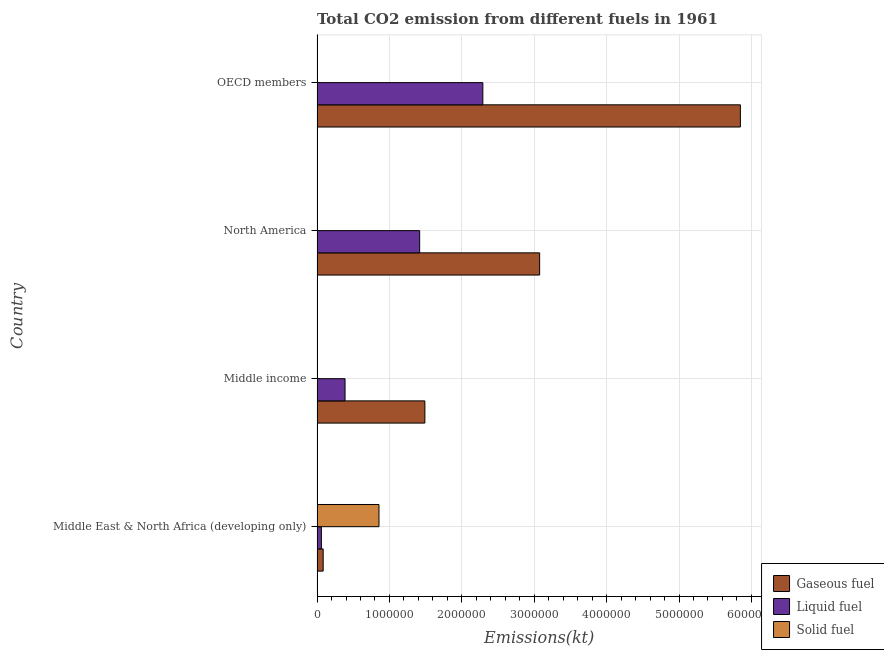How many groups of bars are there?
Your answer should be very brief. 4. Are the number of bars on each tick of the Y-axis equal?
Offer a terse response. Yes. What is the label of the 2nd group of bars from the top?
Your answer should be compact. North America. In how many cases, is the number of bars for a given country not equal to the number of legend labels?
Offer a very short reply. 0. What is the amount of co2 emissions from liquid fuel in Middle East & North Africa (developing only)?
Make the answer very short. 5.98e+04. Across all countries, what is the maximum amount of co2 emissions from gaseous fuel?
Keep it short and to the point. 5.85e+06. Across all countries, what is the minimum amount of co2 emissions from gaseous fuel?
Your response must be concise. 8.46e+04. In which country was the amount of co2 emissions from liquid fuel minimum?
Your answer should be very brief. Middle East & North Africa (developing only). What is the total amount of co2 emissions from gaseous fuel in the graph?
Provide a short and direct response. 1.05e+07. What is the difference between the amount of co2 emissions from liquid fuel in Middle East & North Africa (developing only) and that in OECD members?
Provide a succinct answer. -2.23e+06. What is the difference between the amount of co2 emissions from gaseous fuel in OECD members and the amount of co2 emissions from liquid fuel in Middle East & North Africa (developing only)?
Give a very brief answer. 5.79e+06. What is the average amount of co2 emissions from gaseous fuel per country?
Provide a short and direct response. 2.62e+06. What is the difference between the amount of co2 emissions from solid fuel and amount of co2 emissions from liquid fuel in OECD members?
Provide a short and direct response. -2.29e+06. In how many countries, is the amount of co2 emissions from liquid fuel greater than 5200000 kt?
Offer a terse response. 0. What is the ratio of the amount of co2 emissions from solid fuel in Middle income to that in OECD members?
Provide a succinct answer. 0.23. Is the difference between the amount of co2 emissions from solid fuel in Middle income and OECD members greater than the difference between the amount of co2 emissions from liquid fuel in Middle income and OECD members?
Provide a short and direct response. Yes. What is the difference between the highest and the second highest amount of co2 emissions from solid fuel?
Your response must be concise. 8.55e+05. What is the difference between the highest and the lowest amount of co2 emissions from solid fuel?
Your answer should be compact. 8.55e+05. What does the 3rd bar from the top in Middle East & North Africa (developing only) represents?
Offer a terse response. Gaseous fuel. What does the 1st bar from the bottom in Middle East & North Africa (developing only) represents?
Make the answer very short. Gaseous fuel. How many bars are there?
Keep it short and to the point. 12. Are all the bars in the graph horizontal?
Keep it short and to the point. Yes. Does the graph contain grids?
Ensure brevity in your answer.  Yes. How are the legend labels stacked?
Give a very brief answer. Vertical. What is the title of the graph?
Offer a terse response. Total CO2 emission from different fuels in 1961. What is the label or title of the X-axis?
Provide a succinct answer. Emissions(kt). What is the label or title of the Y-axis?
Make the answer very short. Country. What is the Emissions(kt) of Gaseous fuel in Middle East & North Africa (developing only)?
Your response must be concise. 8.46e+04. What is the Emissions(kt) of Liquid fuel in Middle East & North Africa (developing only)?
Ensure brevity in your answer.  5.98e+04. What is the Emissions(kt) of Solid fuel in Middle East & North Africa (developing only)?
Your response must be concise. 8.56e+05. What is the Emissions(kt) in Gaseous fuel in Middle income?
Make the answer very short. 1.49e+06. What is the Emissions(kt) of Liquid fuel in Middle income?
Provide a succinct answer. 3.87e+05. What is the Emissions(kt) in Solid fuel in Middle income?
Keep it short and to the point. 176.02. What is the Emissions(kt) of Gaseous fuel in North America?
Give a very brief answer. 3.07e+06. What is the Emissions(kt) in Liquid fuel in North America?
Provide a succinct answer. 1.42e+06. What is the Emissions(kt) in Solid fuel in North America?
Offer a terse response. 322.7. What is the Emissions(kt) of Gaseous fuel in OECD members?
Give a very brief answer. 5.85e+06. What is the Emissions(kt) of Liquid fuel in OECD members?
Your answer should be compact. 2.29e+06. What is the Emissions(kt) of Solid fuel in OECD members?
Keep it short and to the point. 766.4. Across all countries, what is the maximum Emissions(kt) in Gaseous fuel?
Your answer should be compact. 5.85e+06. Across all countries, what is the maximum Emissions(kt) of Liquid fuel?
Ensure brevity in your answer.  2.29e+06. Across all countries, what is the maximum Emissions(kt) in Solid fuel?
Your response must be concise. 8.56e+05. Across all countries, what is the minimum Emissions(kt) in Gaseous fuel?
Provide a short and direct response. 8.46e+04. Across all countries, what is the minimum Emissions(kt) in Liquid fuel?
Provide a short and direct response. 5.98e+04. Across all countries, what is the minimum Emissions(kt) of Solid fuel?
Offer a terse response. 176.02. What is the total Emissions(kt) of Gaseous fuel in the graph?
Keep it short and to the point. 1.05e+07. What is the total Emissions(kt) of Liquid fuel in the graph?
Offer a terse response. 4.15e+06. What is the total Emissions(kt) of Solid fuel in the graph?
Your response must be concise. 8.57e+05. What is the difference between the Emissions(kt) in Gaseous fuel in Middle East & North Africa (developing only) and that in Middle income?
Your answer should be compact. -1.40e+06. What is the difference between the Emissions(kt) of Liquid fuel in Middle East & North Africa (developing only) and that in Middle income?
Give a very brief answer. -3.27e+05. What is the difference between the Emissions(kt) of Solid fuel in Middle East & North Africa (developing only) and that in Middle income?
Keep it short and to the point. 8.55e+05. What is the difference between the Emissions(kt) of Gaseous fuel in Middle East & North Africa (developing only) and that in North America?
Give a very brief answer. -2.99e+06. What is the difference between the Emissions(kt) in Liquid fuel in Middle East & North Africa (developing only) and that in North America?
Your response must be concise. -1.36e+06. What is the difference between the Emissions(kt) in Solid fuel in Middle East & North Africa (developing only) and that in North America?
Make the answer very short. 8.55e+05. What is the difference between the Emissions(kt) in Gaseous fuel in Middle East & North Africa (developing only) and that in OECD members?
Ensure brevity in your answer.  -5.76e+06. What is the difference between the Emissions(kt) of Liquid fuel in Middle East & North Africa (developing only) and that in OECD members?
Your answer should be very brief. -2.23e+06. What is the difference between the Emissions(kt) in Solid fuel in Middle East & North Africa (developing only) and that in OECD members?
Make the answer very short. 8.55e+05. What is the difference between the Emissions(kt) in Gaseous fuel in Middle income and that in North America?
Provide a short and direct response. -1.59e+06. What is the difference between the Emissions(kt) in Liquid fuel in Middle income and that in North America?
Your answer should be compact. -1.03e+06. What is the difference between the Emissions(kt) in Solid fuel in Middle income and that in North America?
Offer a terse response. -146.68. What is the difference between the Emissions(kt) in Gaseous fuel in Middle income and that in OECD members?
Your answer should be very brief. -4.36e+06. What is the difference between the Emissions(kt) of Liquid fuel in Middle income and that in OECD members?
Provide a succinct answer. -1.90e+06. What is the difference between the Emissions(kt) of Solid fuel in Middle income and that in OECD members?
Offer a very short reply. -590.39. What is the difference between the Emissions(kt) in Gaseous fuel in North America and that in OECD members?
Provide a short and direct response. -2.77e+06. What is the difference between the Emissions(kt) in Liquid fuel in North America and that in OECD members?
Give a very brief answer. -8.73e+05. What is the difference between the Emissions(kt) of Solid fuel in North America and that in OECD members?
Offer a terse response. -443.71. What is the difference between the Emissions(kt) in Gaseous fuel in Middle East & North Africa (developing only) and the Emissions(kt) in Liquid fuel in Middle income?
Offer a terse response. -3.02e+05. What is the difference between the Emissions(kt) in Gaseous fuel in Middle East & North Africa (developing only) and the Emissions(kt) in Solid fuel in Middle income?
Your response must be concise. 8.45e+04. What is the difference between the Emissions(kt) in Liquid fuel in Middle East & North Africa (developing only) and the Emissions(kt) in Solid fuel in Middle income?
Your response must be concise. 5.96e+04. What is the difference between the Emissions(kt) of Gaseous fuel in Middle East & North Africa (developing only) and the Emissions(kt) of Liquid fuel in North America?
Make the answer very short. -1.33e+06. What is the difference between the Emissions(kt) in Gaseous fuel in Middle East & North Africa (developing only) and the Emissions(kt) in Solid fuel in North America?
Make the answer very short. 8.43e+04. What is the difference between the Emissions(kt) in Liquid fuel in Middle East & North Africa (developing only) and the Emissions(kt) in Solid fuel in North America?
Provide a succinct answer. 5.94e+04. What is the difference between the Emissions(kt) in Gaseous fuel in Middle East & North Africa (developing only) and the Emissions(kt) in Liquid fuel in OECD members?
Give a very brief answer. -2.21e+06. What is the difference between the Emissions(kt) of Gaseous fuel in Middle East & North Africa (developing only) and the Emissions(kt) of Solid fuel in OECD members?
Give a very brief answer. 8.39e+04. What is the difference between the Emissions(kt) in Liquid fuel in Middle East & North Africa (developing only) and the Emissions(kt) in Solid fuel in OECD members?
Your answer should be very brief. 5.90e+04. What is the difference between the Emissions(kt) in Gaseous fuel in Middle income and the Emissions(kt) in Liquid fuel in North America?
Make the answer very short. 7.21e+04. What is the difference between the Emissions(kt) of Gaseous fuel in Middle income and the Emissions(kt) of Solid fuel in North America?
Your answer should be compact. 1.49e+06. What is the difference between the Emissions(kt) in Liquid fuel in Middle income and the Emissions(kt) in Solid fuel in North America?
Keep it short and to the point. 3.86e+05. What is the difference between the Emissions(kt) of Gaseous fuel in Middle income and the Emissions(kt) of Liquid fuel in OECD members?
Provide a succinct answer. -8.01e+05. What is the difference between the Emissions(kt) in Gaseous fuel in Middle income and the Emissions(kt) in Solid fuel in OECD members?
Give a very brief answer. 1.49e+06. What is the difference between the Emissions(kt) of Liquid fuel in Middle income and the Emissions(kt) of Solid fuel in OECD members?
Make the answer very short. 3.86e+05. What is the difference between the Emissions(kt) of Gaseous fuel in North America and the Emissions(kt) of Liquid fuel in OECD members?
Keep it short and to the point. 7.85e+05. What is the difference between the Emissions(kt) in Gaseous fuel in North America and the Emissions(kt) in Solid fuel in OECD members?
Your response must be concise. 3.07e+06. What is the difference between the Emissions(kt) in Liquid fuel in North America and the Emissions(kt) in Solid fuel in OECD members?
Offer a very short reply. 1.42e+06. What is the average Emissions(kt) of Gaseous fuel per country?
Make the answer very short. 2.62e+06. What is the average Emissions(kt) of Liquid fuel per country?
Your response must be concise. 1.04e+06. What is the average Emissions(kt) in Solid fuel per country?
Offer a very short reply. 2.14e+05. What is the difference between the Emissions(kt) of Gaseous fuel and Emissions(kt) of Liquid fuel in Middle East & North Africa (developing only)?
Provide a short and direct response. 2.49e+04. What is the difference between the Emissions(kt) of Gaseous fuel and Emissions(kt) of Solid fuel in Middle East & North Africa (developing only)?
Provide a succinct answer. -7.71e+05. What is the difference between the Emissions(kt) in Liquid fuel and Emissions(kt) in Solid fuel in Middle East & North Africa (developing only)?
Make the answer very short. -7.96e+05. What is the difference between the Emissions(kt) in Gaseous fuel and Emissions(kt) in Liquid fuel in Middle income?
Offer a terse response. 1.10e+06. What is the difference between the Emissions(kt) of Gaseous fuel and Emissions(kt) of Solid fuel in Middle income?
Ensure brevity in your answer.  1.49e+06. What is the difference between the Emissions(kt) of Liquid fuel and Emissions(kt) of Solid fuel in Middle income?
Ensure brevity in your answer.  3.87e+05. What is the difference between the Emissions(kt) in Gaseous fuel and Emissions(kt) in Liquid fuel in North America?
Your answer should be very brief. 1.66e+06. What is the difference between the Emissions(kt) of Gaseous fuel and Emissions(kt) of Solid fuel in North America?
Your answer should be compact. 3.07e+06. What is the difference between the Emissions(kt) of Liquid fuel and Emissions(kt) of Solid fuel in North America?
Provide a short and direct response. 1.42e+06. What is the difference between the Emissions(kt) in Gaseous fuel and Emissions(kt) in Liquid fuel in OECD members?
Provide a short and direct response. 3.56e+06. What is the difference between the Emissions(kt) in Gaseous fuel and Emissions(kt) in Solid fuel in OECD members?
Your answer should be very brief. 5.85e+06. What is the difference between the Emissions(kt) in Liquid fuel and Emissions(kt) in Solid fuel in OECD members?
Keep it short and to the point. 2.29e+06. What is the ratio of the Emissions(kt) in Gaseous fuel in Middle East & North Africa (developing only) to that in Middle income?
Offer a terse response. 0.06. What is the ratio of the Emissions(kt) in Liquid fuel in Middle East & North Africa (developing only) to that in Middle income?
Provide a short and direct response. 0.15. What is the ratio of the Emissions(kt) of Solid fuel in Middle East & North Africa (developing only) to that in Middle income?
Offer a terse response. 4860.98. What is the ratio of the Emissions(kt) of Gaseous fuel in Middle East & North Africa (developing only) to that in North America?
Provide a short and direct response. 0.03. What is the ratio of the Emissions(kt) in Liquid fuel in Middle East & North Africa (developing only) to that in North America?
Your answer should be very brief. 0.04. What is the ratio of the Emissions(kt) of Solid fuel in Middle East & North Africa (developing only) to that in North America?
Provide a succinct answer. 2651.44. What is the ratio of the Emissions(kt) in Gaseous fuel in Middle East & North Africa (developing only) to that in OECD members?
Keep it short and to the point. 0.01. What is the ratio of the Emissions(kt) of Liquid fuel in Middle East & North Africa (developing only) to that in OECD members?
Offer a terse response. 0.03. What is the ratio of the Emissions(kt) of Solid fuel in Middle East & North Africa (developing only) to that in OECD members?
Ensure brevity in your answer.  1116.4. What is the ratio of the Emissions(kt) of Gaseous fuel in Middle income to that in North America?
Your answer should be very brief. 0.48. What is the ratio of the Emissions(kt) of Liquid fuel in Middle income to that in North America?
Offer a terse response. 0.27. What is the ratio of the Emissions(kt) in Solid fuel in Middle income to that in North America?
Provide a succinct answer. 0.55. What is the ratio of the Emissions(kt) in Gaseous fuel in Middle income to that in OECD members?
Your answer should be very brief. 0.25. What is the ratio of the Emissions(kt) in Liquid fuel in Middle income to that in OECD members?
Offer a terse response. 0.17. What is the ratio of the Emissions(kt) of Solid fuel in Middle income to that in OECD members?
Provide a short and direct response. 0.23. What is the ratio of the Emissions(kt) in Gaseous fuel in North America to that in OECD members?
Provide a short and direct response. 0.53. What is the ratio of the Emissions(kt) in Liquid fuel in North America to that in OECD members?
Offer a very short reply. 0.62. What is the ratio of the Emissions(kt) of Solid fuel in North America to that in OECD members?
Keep it short and to the point. 0.42. What is the difference between the highest and the second highest Emissions(kt) of Gaseous fuel?
Your answer should be compact. 2.77e+06. What is the difference between the highest and the second highest Emissions(kt) of Liquid fuel?
Your response must be concise. 8.73e+05. What is the difference between the highest and the second highest Emissions(kt) of Solid fuel?
Keep it short and to the point. 8.55e+05. What is the difference between the highest and the lowest Emissions(kt) in Gaseous fuel?
Provide a succinct answer. 5.76e+06. What is the difference between the highest and the lowest Emissions(kt) in Liquid fuel?
Keep it short and to the point. 2.23e+06. What is the difference between the highest and the lowest Emissions(kt) of Solid fuel?
Offer a terse response. 8.55e+05. 